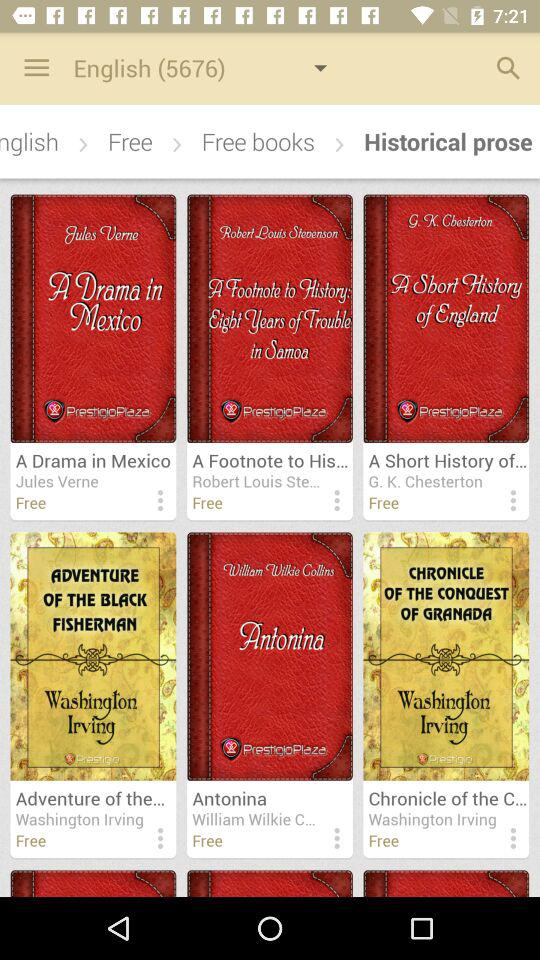Which tab am I on? You are on the "RECENTS" tab. 